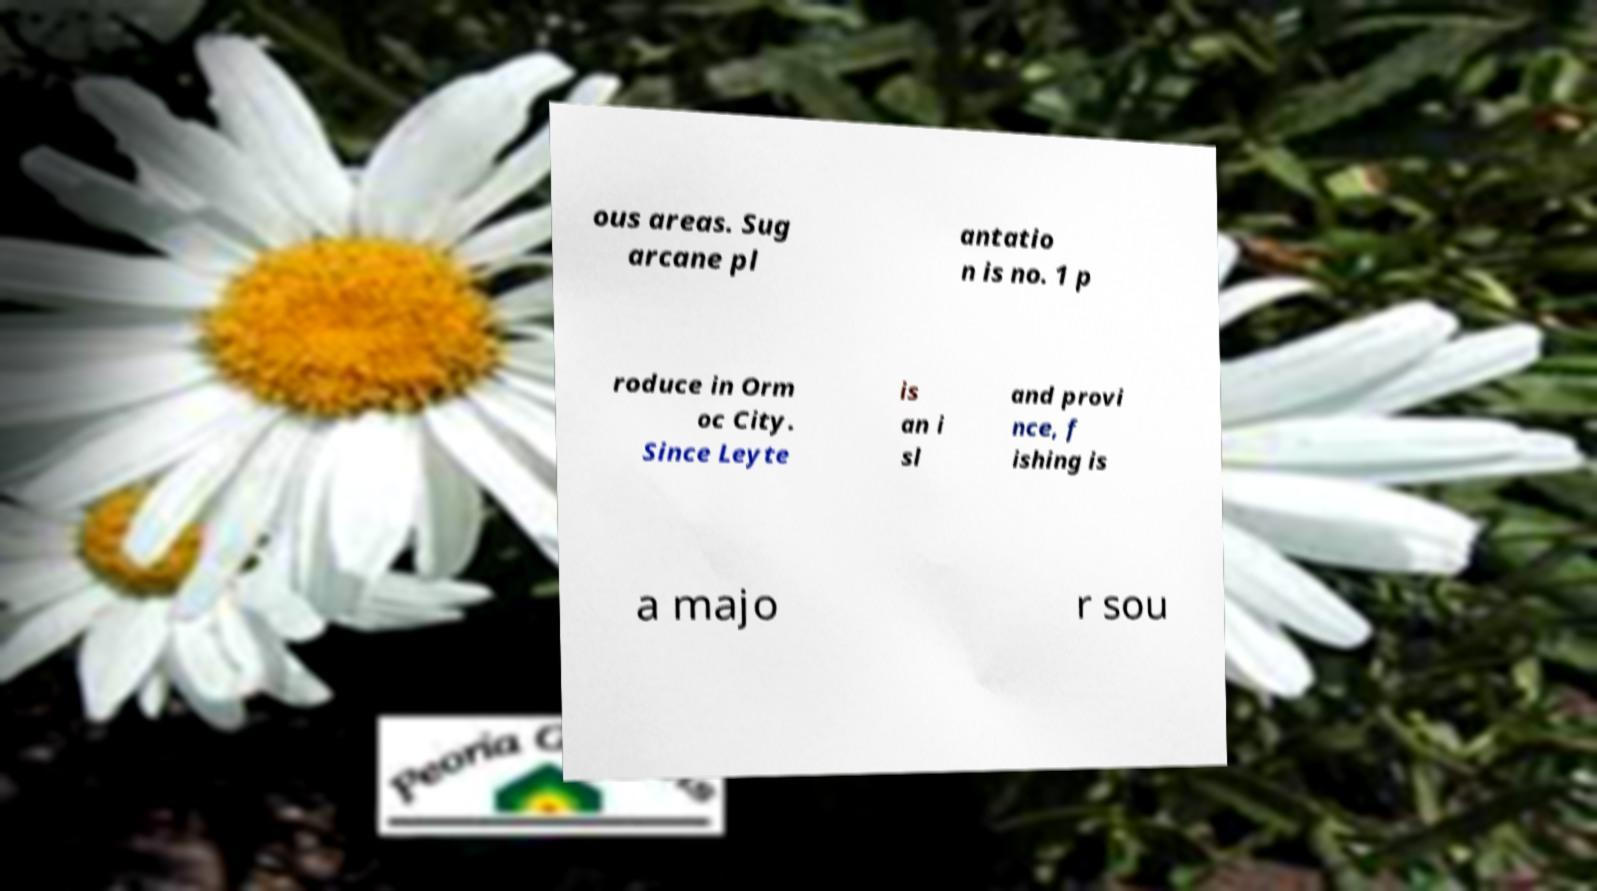For documentation purposes, I need the text within this image transcribed. Could you provide that? ous areas. Sug arcane pl antatio n is no. 1 p roduce in Orm oc City. Since Leyte is an i sl and provi nce, f ishing is a majo r sou 